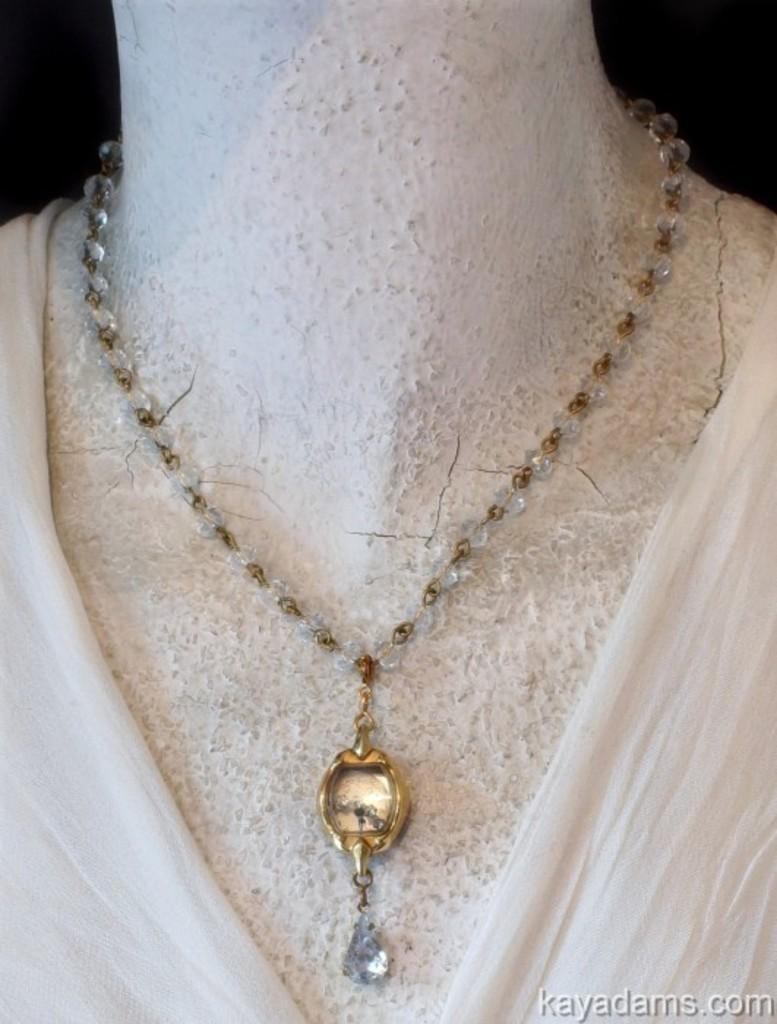Can you describe this image briefly? In this picture there is a mannequin, to the mannequin there is a necklace and a white cloth. 